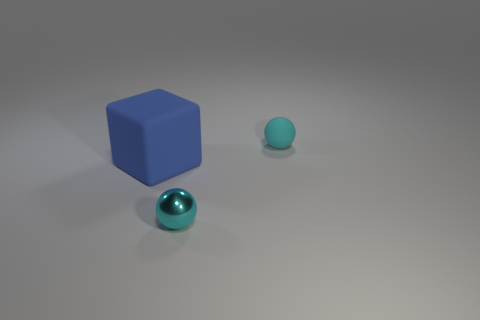Can you describe the overall setting and mood this image conveys? The image presents a tranquil scene with a minimalist arrangement. A blue cube and two spheres are thoughtfully placed in a neutral space with soft lighting, evoking a serene and contemplative mood. 